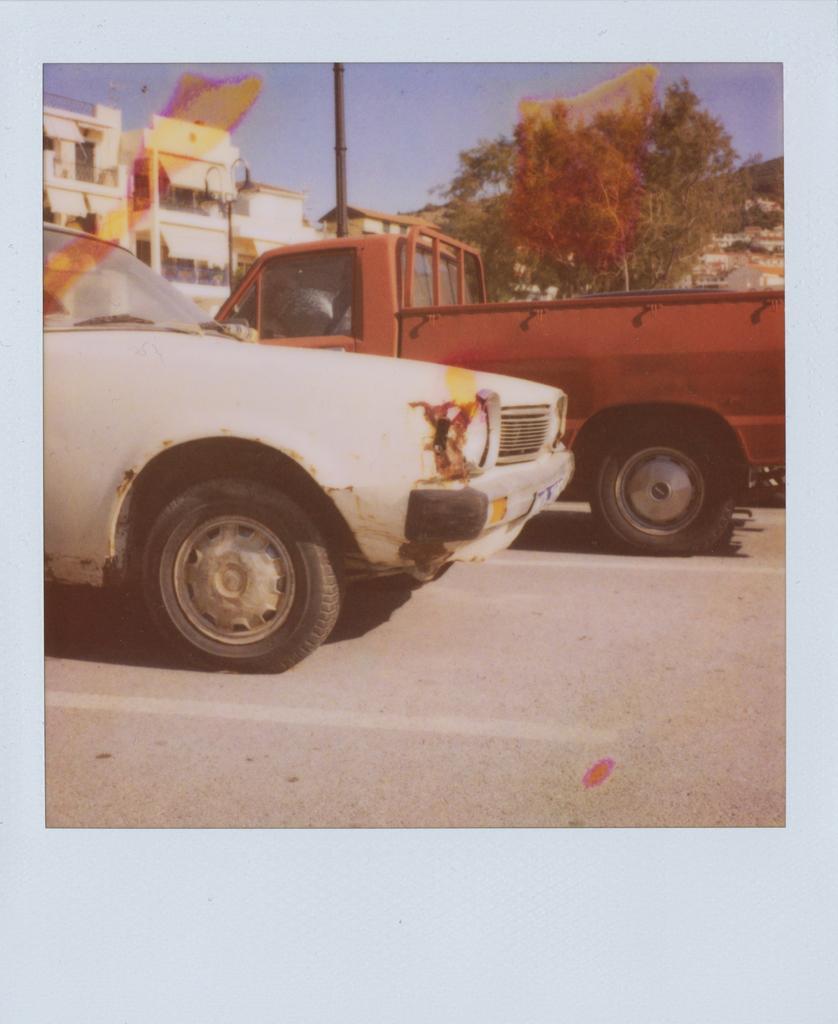Can you describe this image briefly? In this picture I can see couple of vehicles parked and I can see trees and buildings in the back. I can see a pole and a blue sky. 